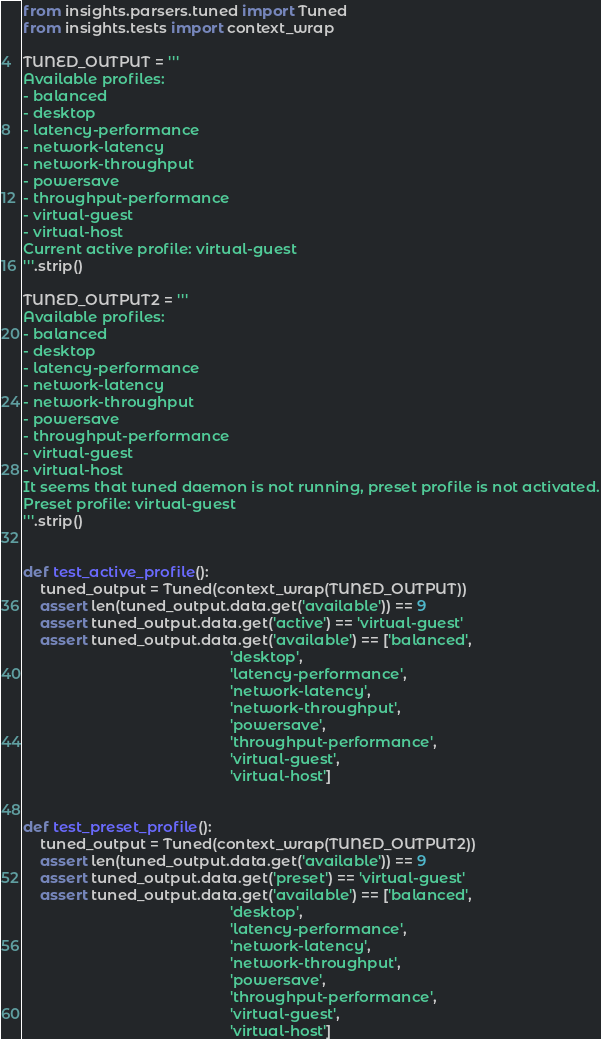Convert code to text. <code><loc_0><loc_0><loc_500><loc_500><_Python_>from insights.parsers.tuned import Tuned
from insights.tests import context_wrap

TUNED_OUTPUT = '''
Available profiles:
- balanced
- desktop
- latency-performance
- network-latency
- network-throughput
- powersave
- throughput-performance
- virtual-guest
- virtual-host
Current active profile: virtual-guest
'''.strip()

TUNED_OUTPUT2 = '''
Available profiles:
- balanced
- desktop
- latency-performance
- network-latency
- network-throughput
- powersave
- throughput-performance
- virtual-guest
- virtual-host
It seems that tuned daemon is not running, preset profile is not activated.
Preset profile: virtual-guest
'''.strip()


def test_active_profile():
    tuned_output = Tuned(context_wrap(TUNED_OUTPUT))
    assert len(tuned_output.data.get('available')) == 9
    assert tuned_output.data.get('active') == 'virtual-guest'
    assert tuned_output.data.get('available') == ['balanced',
                                                  'desktop',
                                                  'latency-performance',
                                                  'network-latency',
                                                  'network-throughput',
                                                  'powersave',
                                                  'throughput-performance',
                                                  'virtual-guest',
                                                  'virtual-host']


def test_preset_profile():
    tuned_output = Tuned(context_wrap(TUNED_OUTPUT2))
    assert len(tuned_output.data.get('available')) == 9
    assert tuned_output.data.get('preset') == 'virtual-guest'
    assert tuned_output.data.get('available') == ['balanced',
                                                  'desktop',
                                                  'latency-performance',
                                                  'network-latency',
                                                  'network-throughput',
                                                  'powersave',
                                                  'throughput-performance',
                                                  'virtual-guest',
                                                  'virtual-host']
</code> 